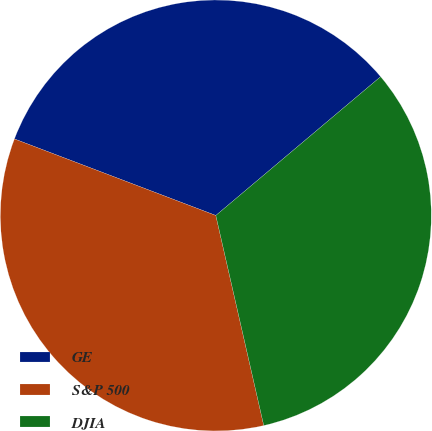<chart> <loc_0><loc_0><loc_500><loc_500><pie_chart><fcel>GE<fcel>S&P 500<fcel>DJIA<nl><fcel>33.08%<fcel>34.35%<fcel>32.57%<nl></chart> 